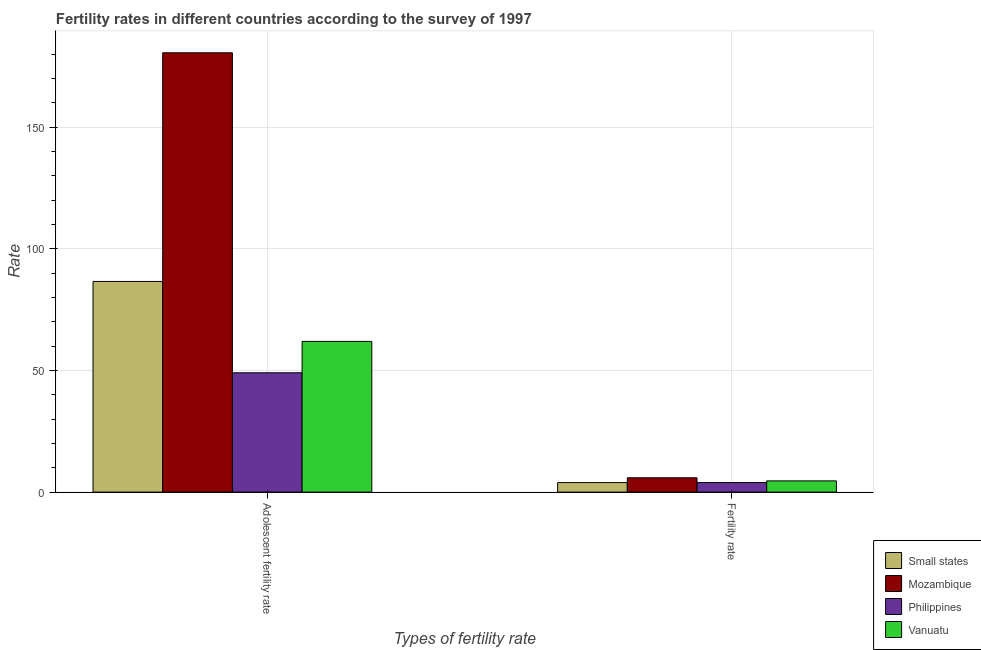How many groups of bars are there?
Give a very brief answer. 2. What is the label of the 2nd group of bars from the left?
Ensure brevity in your answer.  Fertility rate. What is the adolescent fertility rate in Small states?
Your answer should be compact. 86.61. Across all countries, what is the maximum adolescent fertility rate?
Provide a succinct answer. 180.62. Across all countries, what is the minimum fertility rate?
Offer a very short reply. 3.91. In which country was the adolescent fertility rate maximum?
Keep it short and to the point. Mozambique. In which country was the fertility rate minimum?
Offer a terse response. Small states. What is the total fertility rate in the graph?
Give a very brief answer. 18.33. What is the difference between the adolescent fertility rate in Philippines and that in Vanuatu?
Your answer should be compact. -12.9. What is the difference between the fertility rate in Vanuatu and the adolescent fertility rate in Small states?
Provide a short and direct response. -81.99. What is the average fertility rate per country?
Offer a terse response. 4.58. What is the difference between the fertility rate and adolescent fertility rate in Vanuatu?
Offer a very short reply. -57.35. What is the ratio of the fertility rate in Mozambique to that in Small states?
Ensure brevity in your answer.  1.51. Is the fertility rate in Mozambique less than that in Philippines?
Offer a terse response. No. What does the 2nd bar from the left in Adolescent fertility rate represents?
Your answer should be compact. Mozambique. What does the 1st bar from the right in Adolescent fertility rate represents?
Provide a succinct answer. Vanuatu. Are all the bars in the graph horizontal?
Offer a terse response. No. How many countries are there in the graph?
Your answer should be very brief. 4. What is the difference between two consecutive major ticks on the Y-axis?
Ensure brevity in your answer.  50. Are the values on the major ticks of Y-axis written in scientific E-notation?
Offer a terse response. No. Where does the legend appear in the graph?
Provide a succinct answer. Bottom right. What is the title of the graph?
Offer a very short reply. Fertility rates in different countries according to the survey of 1997. What is the label or title of the X-axis?
Make the answer very short. Types of fertility rate. What is the label or title of the Y-axis?
Your answer should be compact. Rate. What is the Rate in Small states in Adolescent fertility rate?
Provide a succinct answer. 86.61. What is the Rate in Mozambique in Adolescent fertility rate?
Provide a short and direct response. 180.62. What is the Rate in Philippines in Adolescent fertility rate?
Keep it short and to the point. 49.06. What is the Rate in Vanuatu in Adolescent fertility rate?
Keep it short and to the point. 61.97. What is the Rate in Small states in Fertility rate?
Give a very brief answer. 3.91. What is the Rate of Mozambique in Fertility rate?
Ensure brevity in your answer.  5.88. What is the Rate in Philippines in Fertility rate?
Ensure brevity in your answer.  3.92. What is the Rate of Vanuatu in Fertility rate?
Your answer should be compact. 4.61. Across all Types of fertility rate, what is the maximum Rate of Small states?
Provide a succinct answer. 86.61. Across all Types of fertility rate, what is the maximum Rate in Mozambique?
Your response must be concise. 180.62. Across all Types of fertility rate, what is the maximum Rate of Philippines?
Provide a short and direct response. 49.06. Across all Types of fertility rate, what is the maximum Rate of Vanuatu?
Offer a very short reply. 61.97. Across all Types of fertility rate, what is the minimum Rate of Small states?
Keep it short and to the point. 3.91. Across all Types of fertility rate, what is the minimum Rate in Mozambique?
Your answer should be very brief. 5.88. Across all Types of fertility rate, what is the minimum Rate in Philippines?
Ensure brevity in your answer.  3.92. Across all Types of fertility rate, what is the minimum Rate of Vanuatu?
Offer a terse response. 4.61. What is the total Rate of Small states in the graph?
Offer a terse response. 90.52. What is the total Rate of Mozambique in the graph?
Your answer should be very brief. 186.5. What is the total Rate in Philippines in the graph?
Your response must be concise. 52.98. What is the total Rate in Vanuatu in the graph?
Your answer should be compact. 66.58. What is the difference between the Rate in Small states in Adolescent fertility rate and that in Fertility rate?
Your answer should be very brief. 82.7. What is the difference between the Rate of Mozambique in Adolescent fertility rate and that in Fertility rate?
Make the answer very short. 174.73. What is the difference between the Rate of Philippines in Adolescent fertility rate and that in Fertility rate?
Provide a short and direct response. 45.14. What is the difference between the Rate in Vanuatu in Adolescent fertility rate and that in Fertility rate?
Offer a very short reply. 57.35. What is the difference between the Rate of Small states in Adolescent fertility rate and the Rate of Mozambique in Fertility rate?
Provide a short and direct response. 80.72. What is the difference between the Rate in Small states in Adolescent fertility rate and the Rate in Philippines in Fertility rate?
Make the answer very short. 82.68. What is the difference between the Rate in Small states in Adolescent fertility rate and the Rate in Vanuatu in Fertility rate?
Your answer should be very brief. 81.99. What is the difference between the Rate of Mozambique in Adolescent fertility rate and the Rate of Philippines in Fertility rate?
Offer a very short reply. 176.69. What is the difference between the Rate of Mozambique in Adolescent fertility rate and the Rate of Vanuatu in Fertility rate?
Give a very brief answer. 176. What is the difference between the Rate of Philippines in Adolescent fertility rate and the Rate of Vanuatu in Fertility rate?
Offer a terse response. 44.45. What is the average Rate of Small states per Types of fertility rate?
Provide a succinct answer. 45.26. What is the average Rate in Mozambique per Types of fertility rate?
Provide a short and direct response. 93.25. What is the average Rate of Philippines per Types of fertility rate?
Keep it short and to the point. 26.49. What is the average Rate in Vanuatu per Types of fertility rate?
Give a very brief answer. 33.29. What is the difference between the Rate of Small states and Rate of Mozambique in Adolescent fertility rate?
Provide a succinct answer. -94.01. What is the difference between the Rate in Small states and Rate in Philippines in Adolescent fertility rate?
Offer a very short reply. 37.55. What is the difference between the Rate of Small states and Rate of Vanuatu in Adolescent fertility rate?
Provide a succinct answer. 24.64. What is the difference between the Rate in Mozambique and Rate in Philippines in Adolescent fertility rate?
Keep it short and to the point. 131.55. What is the difference between the Rate in Mozambique and Rate in Vanuatu in Adolescent fertility rate?
Offer a very short reply. 118.65. What is the difference between the Rate of Philippines and Rate of Vanuatu in Adolescent fertility rate?
Ensure brevity in your answer.  -12.9. What is the difference between the Rate of Small states and Rate of Mozambique in Fertility rate?
Your response must be concise. -1.98. What is the difference between the Rate in Small states and Rate in Philippines in Fertility rate?
Your answer should be very brief. -0.02. What is the difference between the Rate of Small states and Rate of Vanuatu in Fertility rate?
Offer a terse response. -0.71. What is the difference between the Rate of Mozambique and Rate of Philippines in Fertility rate?
Provide a short and direct response. 1.96. What is the difference between the Rate of Mozambique and Rate of Vanuatu in Fertility rate?
Provide a short and direct response. 1.27. What is the difference between the Rate of Philippines and Rate of Vanuatu in Fertility rate?
Keep it short and to the point. -0.69. What is the ratio of the Rate in Small states in Adolescent fertility rate to that in Fertility rate?
Provide a succinct answer. 22.17. What is the ratio of the Rate in Mozambique in Adolescent fertility rate to that in Fertility rate?
Your answer should be compact. 30.7. What is the ratio of the Rate of Philippines in Adolescent fertility rate to that in Fertility rate?
Provide a succinct answer. 12.51. What is the ratio of the Rate in Vanuatu in Adolescent fertility rate to that in Fertility rate?
Your response must be concise. 13.43. What is the difference between the highest and the second highest Rate of Small states?
Give a very brief answer. 82.7. What is the difference between the highest and the second highest Rate in Mozambique?
Make the answer very short. 174.73. What is the difference between the highest and the second highest Rate of Philippines?
Make the answer very short. 45.14. What is the difference between the highest and the second highest Rate in Vanuatu?
Give a very brief answer. 57.35. What is the difference between the highest and the lowest Rate of Small states?
Make the answer very short. 82.7. What is the difference between the highest and the lowest Rate of Mozambique?
Make the answer very short. 174.73. What is the difference between the highest and the lowest Rate in Philippines?
Offer a terse response. 45.14. What is the difference between the highest and the lowest Rate of Vanuatu?
Ensure brevity in your answer.  57.35. 